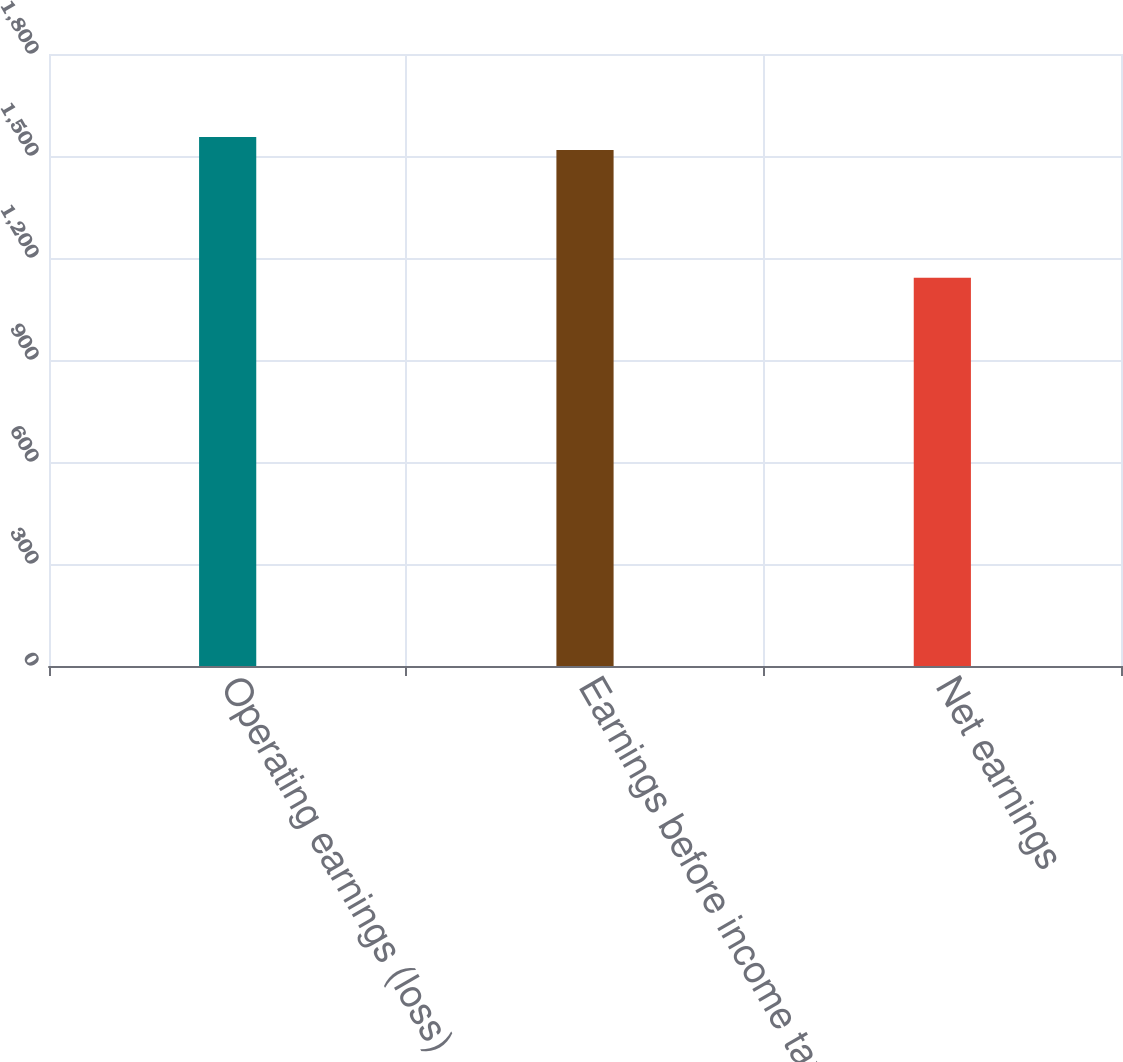<chart> <loc_0><loc_0><loc_500><loc_500><bar_chart><fcel>Operating earnings (loss)<fcel>Earnings before income taxes<fcel>Net earnings<nl><fcel>1555.81<fcel>1517.4<fcel>1141.9<nl></chart> 